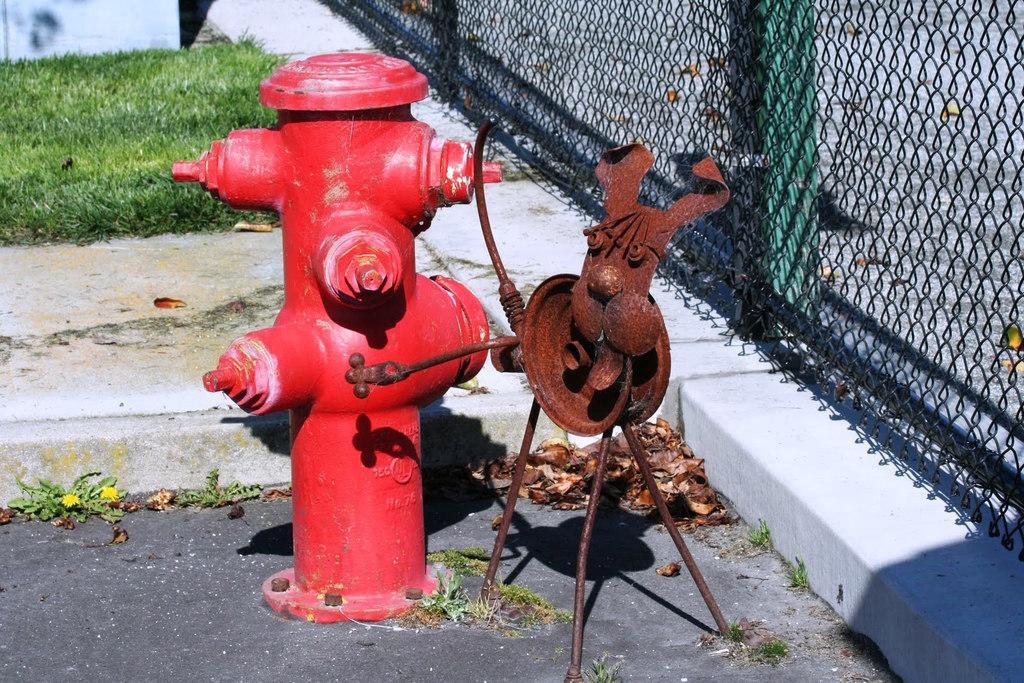Could you give a brief overview of what you see in this image? This is the picture of a fire hydrant and a object on the floor and to the side there is a fencing and also we can see some grass behind. 